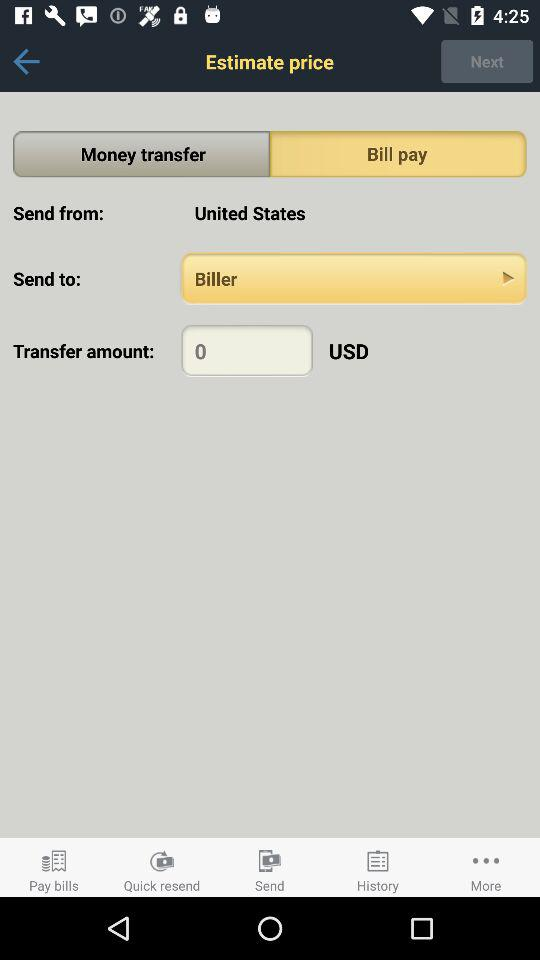In what currency is the amount transferred? The amount is transferred in USD. 